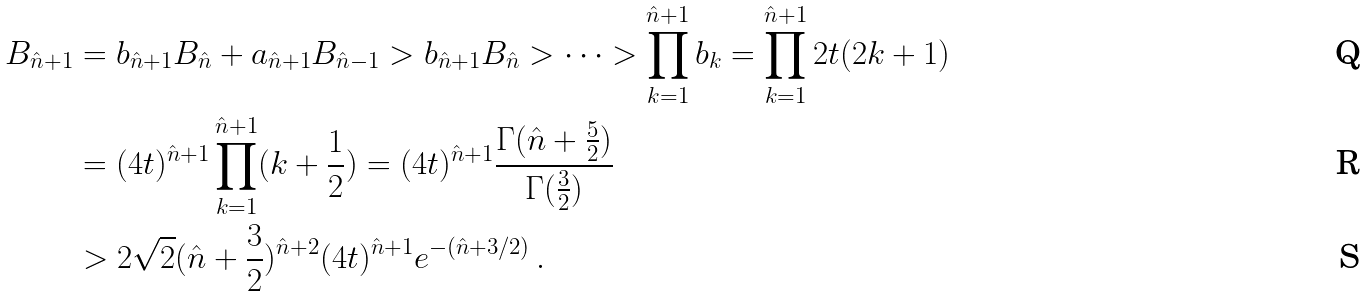<formula> <loc_0><loc_0><loc_500><loc_500>B _ { \hat { n } + 1 } & = b _ { \hat { n } + 1 } B _ { \hat { n } } + a _ { \hat { n } + 1 } B _ { \hat { n } - 1 } > b _ { \hat { n } + 1 } B _ { \hat { n } } > \cdots > \prod _ { k = 1 } ^ { \hat { n } + 1 } b _ { k } = \prod _ { k = 1 } ^ { \hat { n } + 1 } 2 t ( 2 k + 1 ) \\ & = ( 4 t ) ^ { \hat { n } + 1 } \prod _ { k = 1 } ^ { \hat { n } + 1 } ( k + \frac { 1 } { 2 } ) = ( 4 t ) ^ { \hat { n } + 1 } \frac { \Gamma ( \hat { n } + \frac { 5 } { 2 } ) } { \Gamma ( \frac { 3 } { 2 } ) } \\ & > 2 \sqrt { 2 } ( \hat { n } + \frac { 3 } { 2 } ) ^ { \hat { n } + 2 } ( 4 t ) ^ { \hat { n } + 1 } e ^ { - ( \hat { n } + 3 / 2 ) } \, .</formula> 